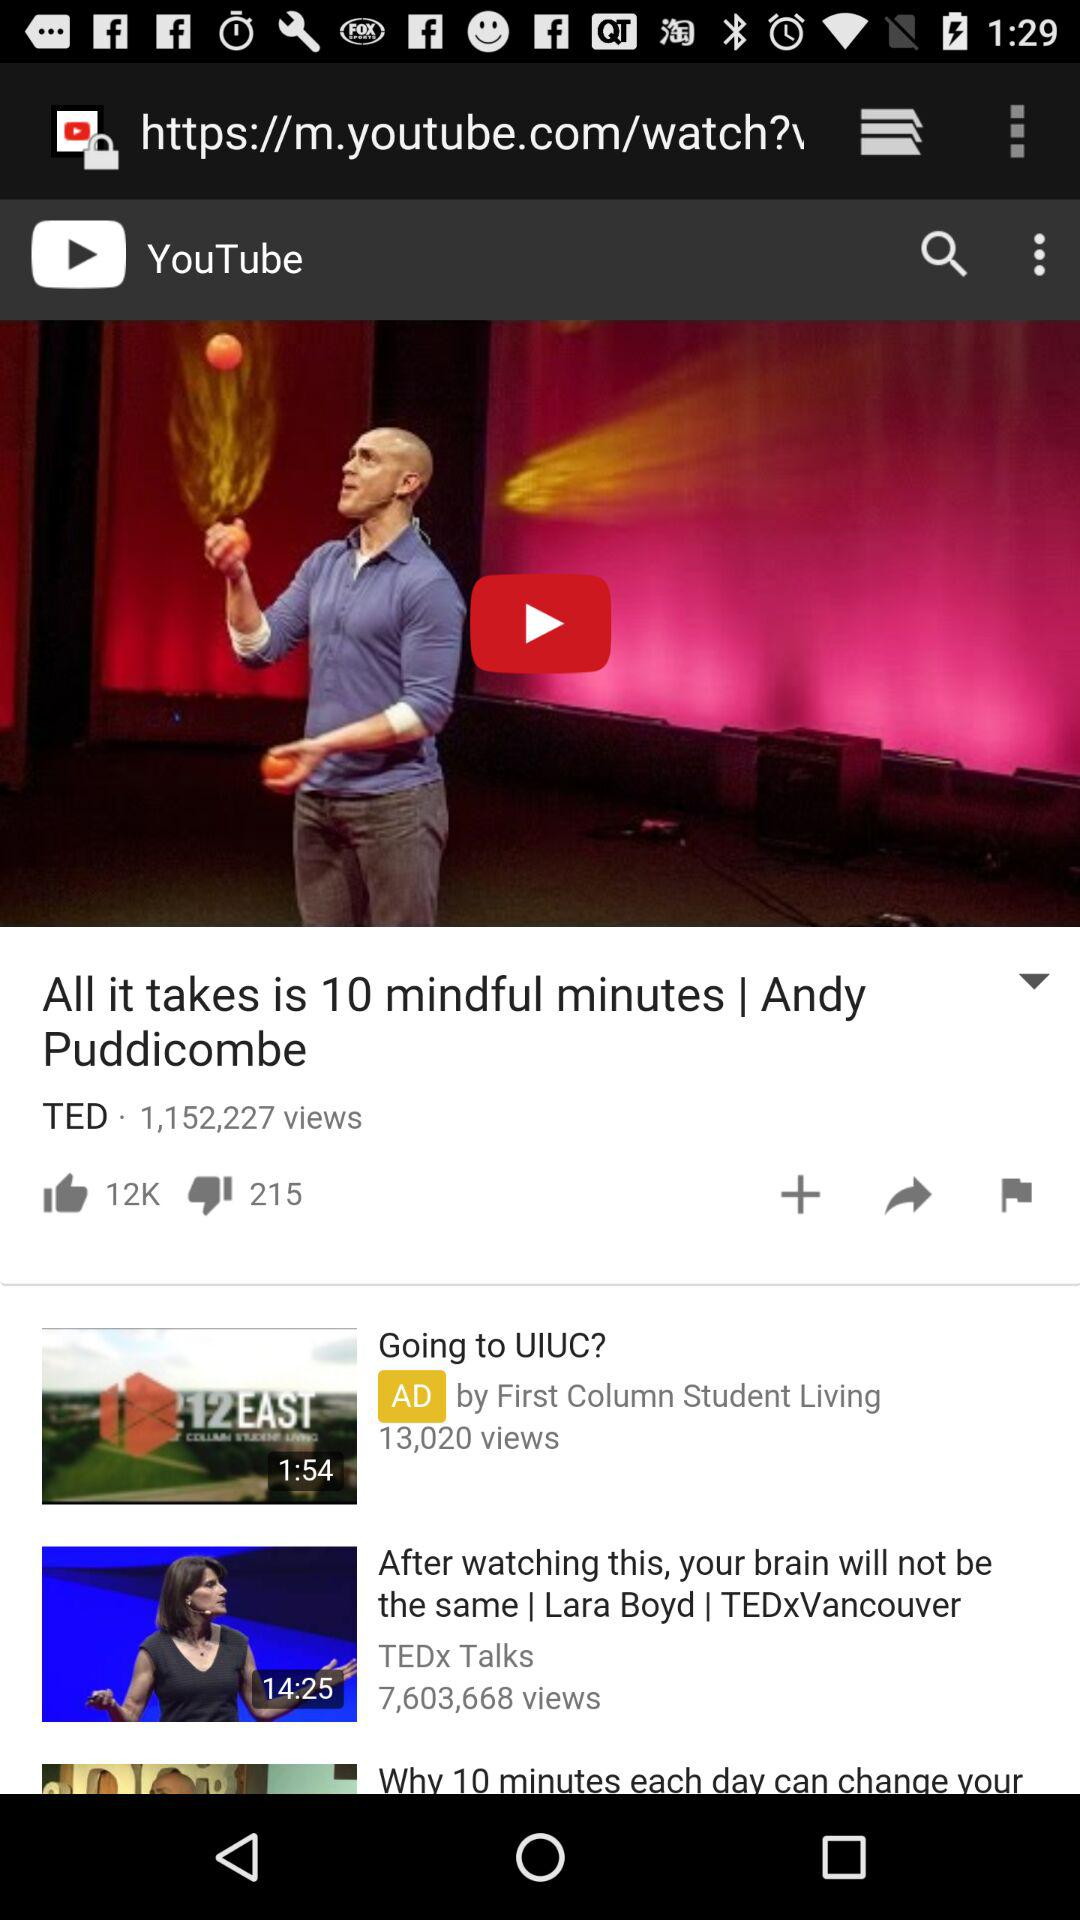How many likes in total are there on the video "All it takes is 10 mindful minutes | Andy Puddicombe"? There are 12k likes on the video. 